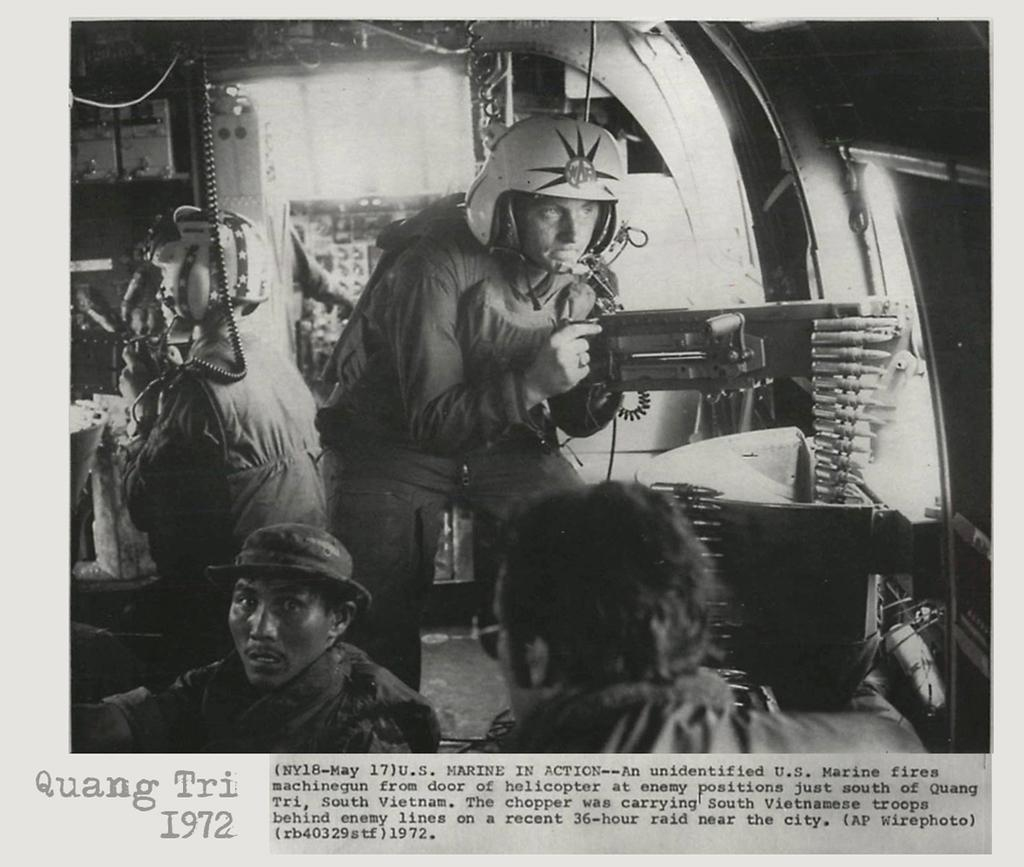What is the main subject of the image? The main subject of the image is an article. Are there any people present in the image? Yes, there are people in the image. What type of protective gear can be seen in the image? Helmets are visible in the image. What else can be found in the image besides the article and people? There are objects in the image. What information is provided on the article? Something is written on the article. What type of wrist support is visible in the image? There is no wrist support present in the image. What year is depicted in the image? The provided facts do not mention any specific year or time period, so it cannot be determined from the image. 